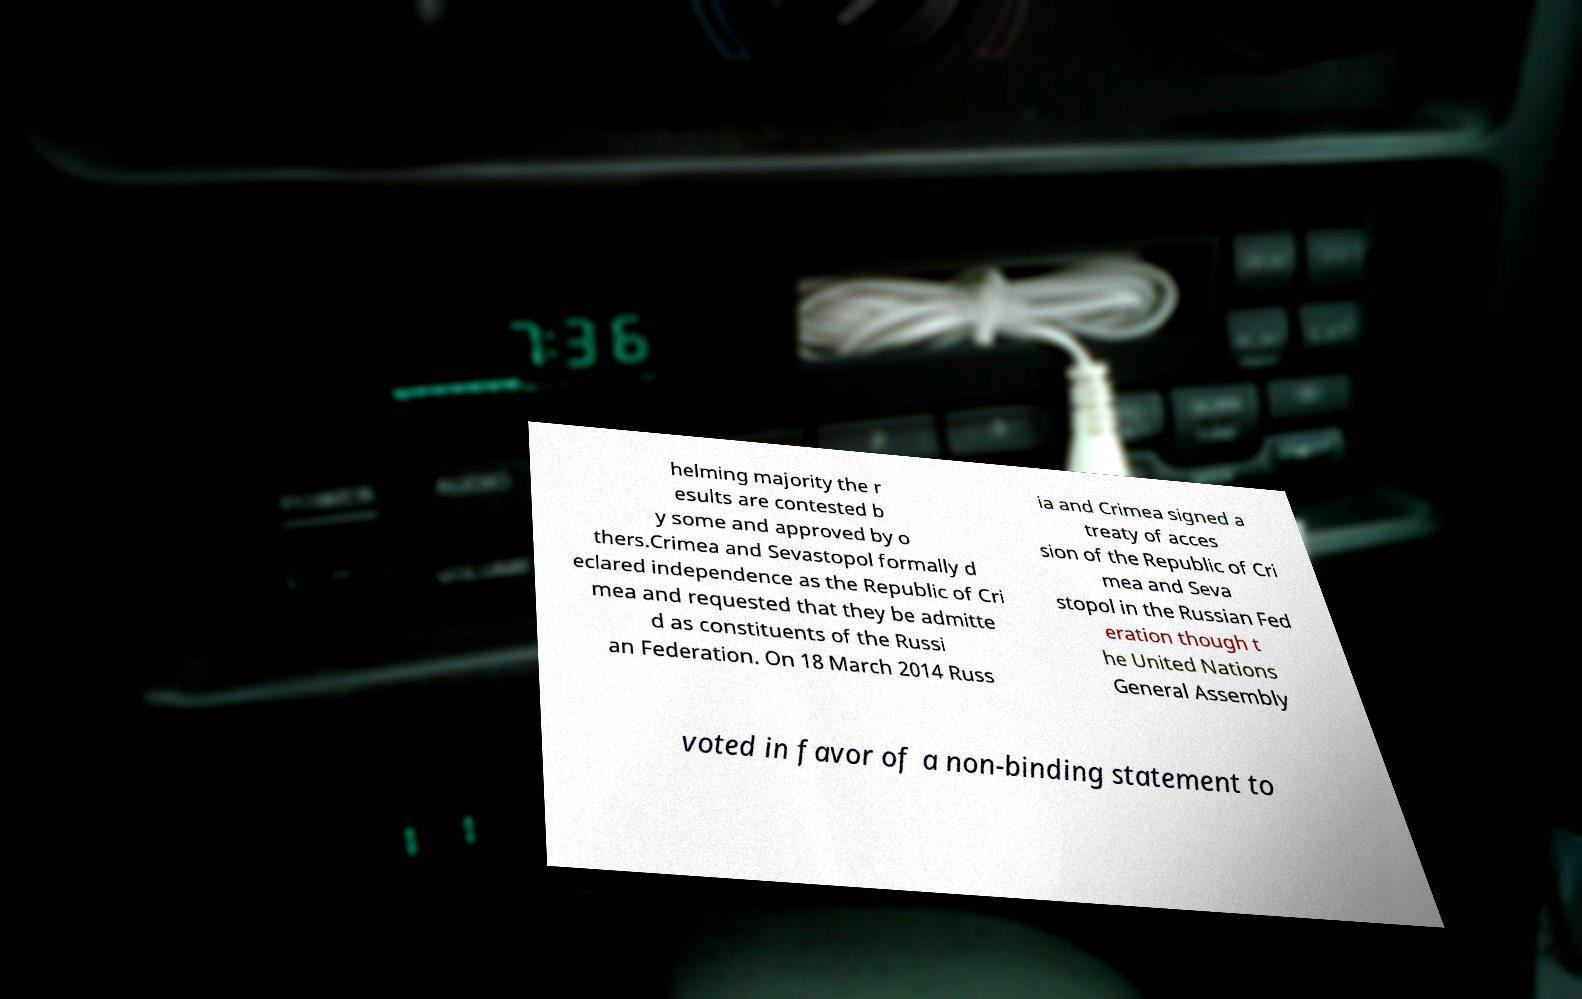Please identify and transcribe the text found in this image. helming majority the r esults are contested b y some and approved by o thers.Crimea and Sevastopol formally d eclared independence as the Republic of Cri mea and requested that they be admitte d as constituents of the Russi an Federation. On 18 March 2014 Russ ia and Crimea signed a treaty of acces sion of the Republic of Cri mea and Seva stopol in the Russian Fed eration though t he United Nations General Assembly voted in favor of a non-binding statement to 